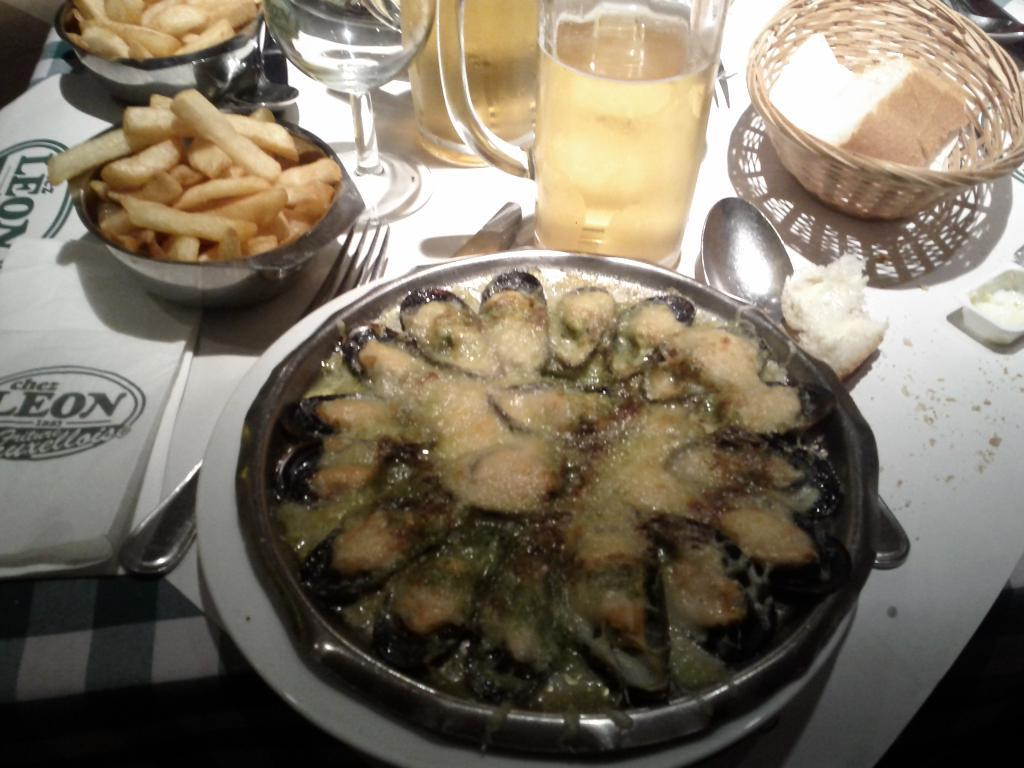What type of food items can be seen on the plate in the image? There is a plate of food items in the image, but the specific types of food cannot be determined from the provided facts. How many bowls of food items are visible in the image? There are bowls of food items in the image, but the exact number cannot be determined from the provided facts. What is the purpose of the basket in the image? The purpose of the basket in the image cannot be determined from the provided facts. What types of drinks are in the glasses in the image? The types of drinks in the glasses in the image cannot be determined from the provided facts. What utensils are visible in the image? Spoons and forks are present in the image. What can be used for cleaning or wiping in the image? Tissues are present in the image for cleaning or wiping. What color is the table in the image? The table is white. Can you tell me how many crows are sitting on the table in the image? There are no crows present in the image. What is the plot of the story being told in the image? The image does not depict a story or plot; it is a still image of a table setting. 